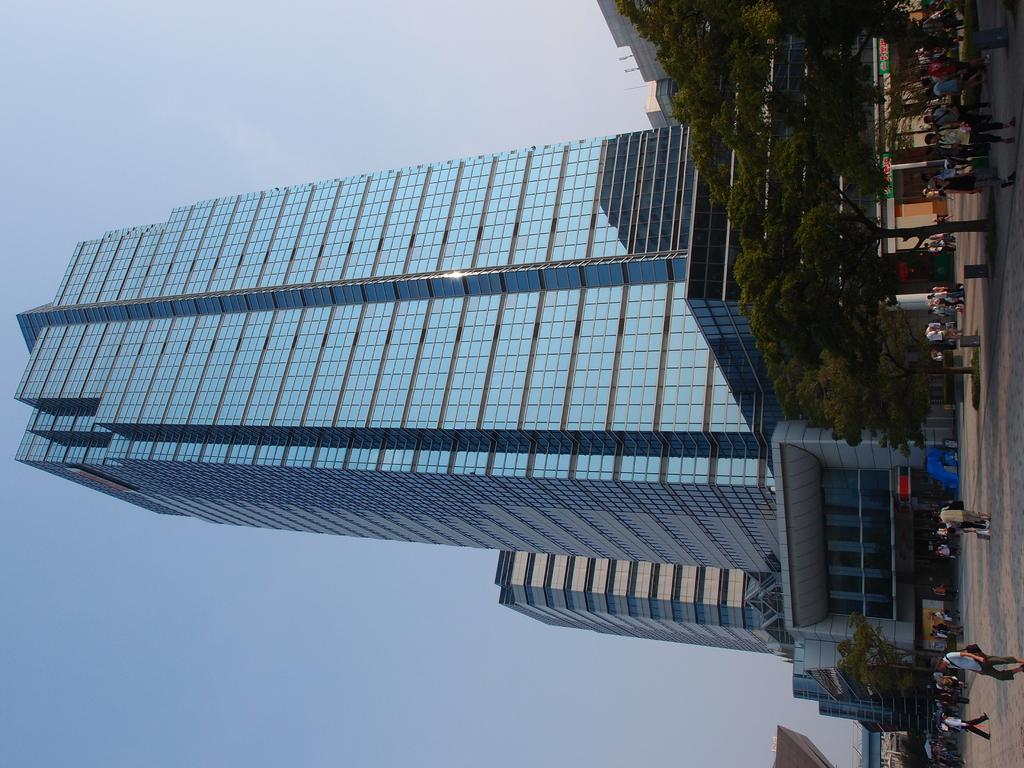What is happening on the ground in the image? There are people on the ground in the image. What type of structures can be seen in the image? There are buildings visible in the image. What else can be seen in the image besides people and buildings? There are trees and some objects in the image. What can be seen in the background of the image? The sky is visible in the background of the image. What type of glass is being used to make noise in the image? There is no glass or noise present in the image. What kind of stick can be seen in the hands of the people in the image? There are no sticks present in the image; the people are not holding any objects. 